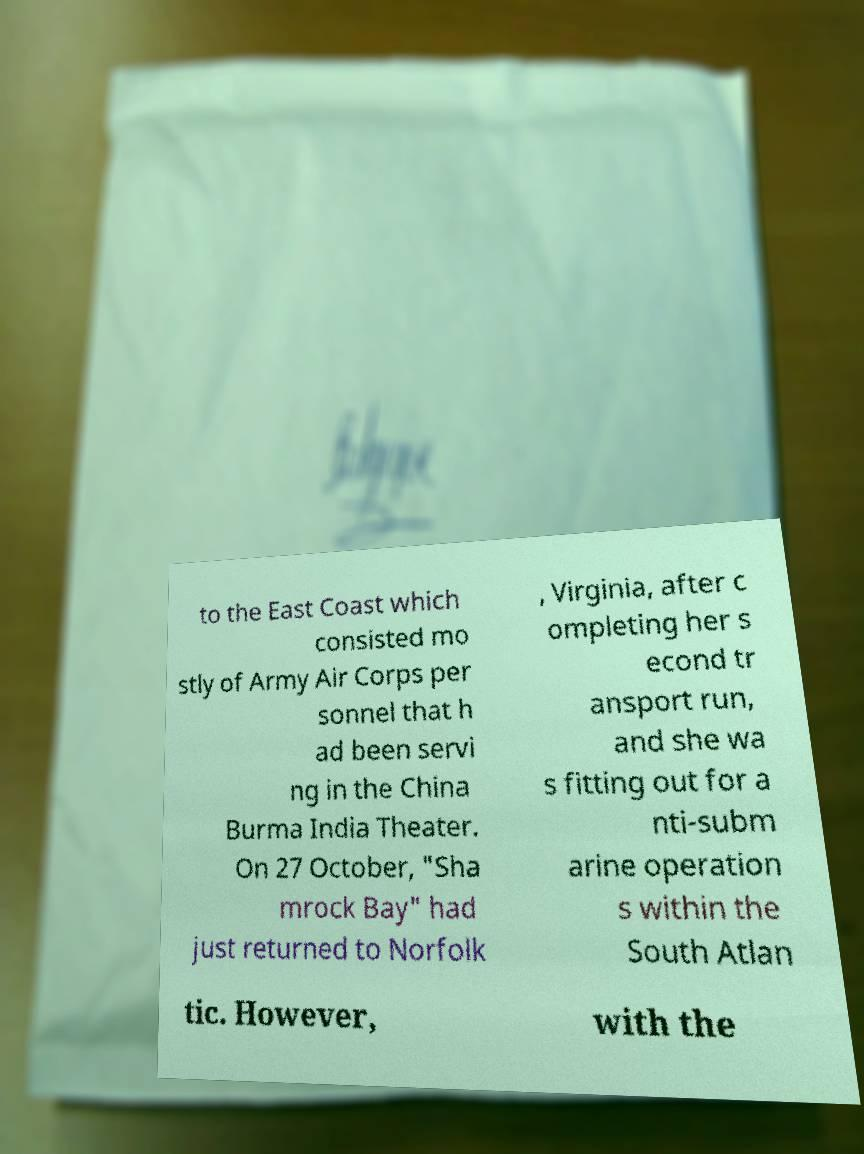There's text embedded in this image that I need extracted. Can you transcribe it verbatim? to the East Coast which consisted mo stly of Army Air Corps per sonnel that h ad been servi ng in the China Burma India Theater. On 27 October, "Sha mrock Bay" had just returned to Norfolk , Virginia, after c ompleting her s econd tr ansport run, and she wa s fitting out for a nti-subm arine operation s within the South Atlan tic. However, with the 